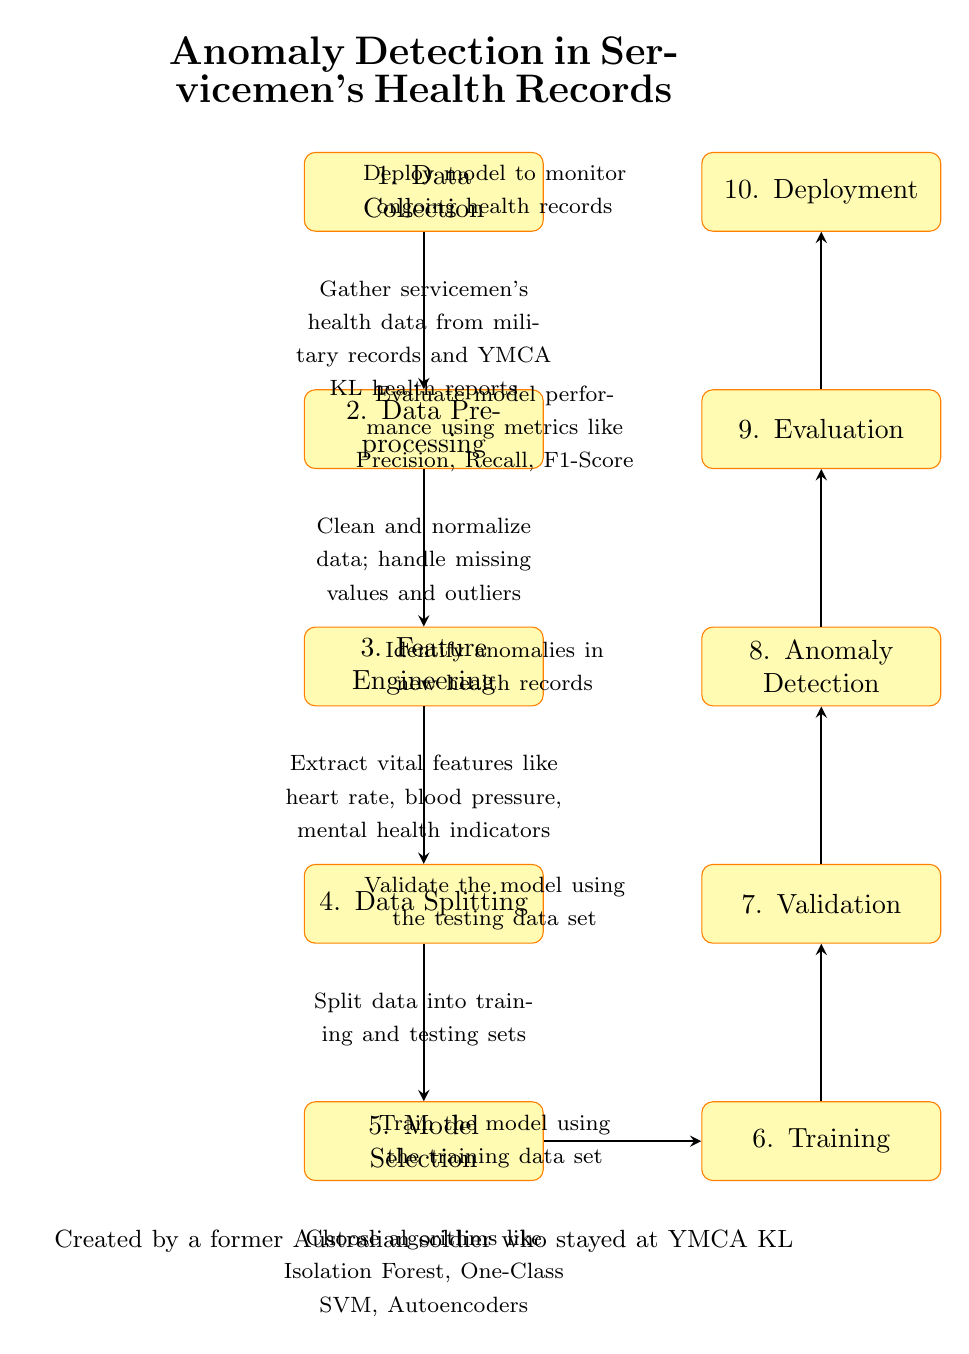What is the first step in the diagram? The first step is represented in the node labeled "1" and is directly connected at the top of the diagram, indicating it is the starting point of the process flow.
Answer: Data Collection What comes after Data Preprocessing? The node following "Data Preprocessing" is "Feature Engineering", which is directly below it, indicating the next step in the process.
Answer: Feature Engineering How many main process nodes are in the diagram? By counting each of the rectangular nodes labeled from 1 to 10, there are a total of ten process nodes that describe the steps in the anomaly detection workflow.
Answer: Ten What does the model select in step 5? In step 5, which is labeled "Model Selection", the focus is on choosing the algorithms for anomaly detection from several options, as stated in the details of that node.
Answer: Algorithms like Isolation Forest, One-Class SVM, Autoencoders Which process evaluates model performance? The evaluation of model performance is described in node 9, which explicitly states "Evaluate model performance using metrics like Precision, Recall, F1-Score".
Answer: Evaluation What is the relationship between Training and Validation steps? The "Training" step (node 6) precedes the "Validation" step (node 7) in the diagram, indicating that training must occur before validation can take place.
Answer: Training proceeds Validation What is the output of the Anomaly Detection step? The output described in step 8, labeled "Anomaly Detection", is the identification of anomalies in new health records, indicating the direct result of this process.
Answer: Identify anomalies in new health records What is the main purpose of the diagram? The main purpose, as stated in the title at the top of the diagram, is to outline the process of Anomaly Detection in Servicemen's Health Records, which encompasses various steps to achieve this goal.
Answer: Anomaly Detection in Servicemen's Health Records Which step follows Model Selection and is crucial for the process? The step that follows "Model Selection" (step 5) is "Training" (step 6), indicating that after selecting a model, training it is essential to the process.
Answer: Training What is noted at the bottom of the diagram? The bottom of the diagram contains a note stating “Created by a former Australian soldier who stayed at YMCA KL”, providing context for the diagram's creation.
Answer: Created by a former Australian soldier who stayed at YMCA KL 